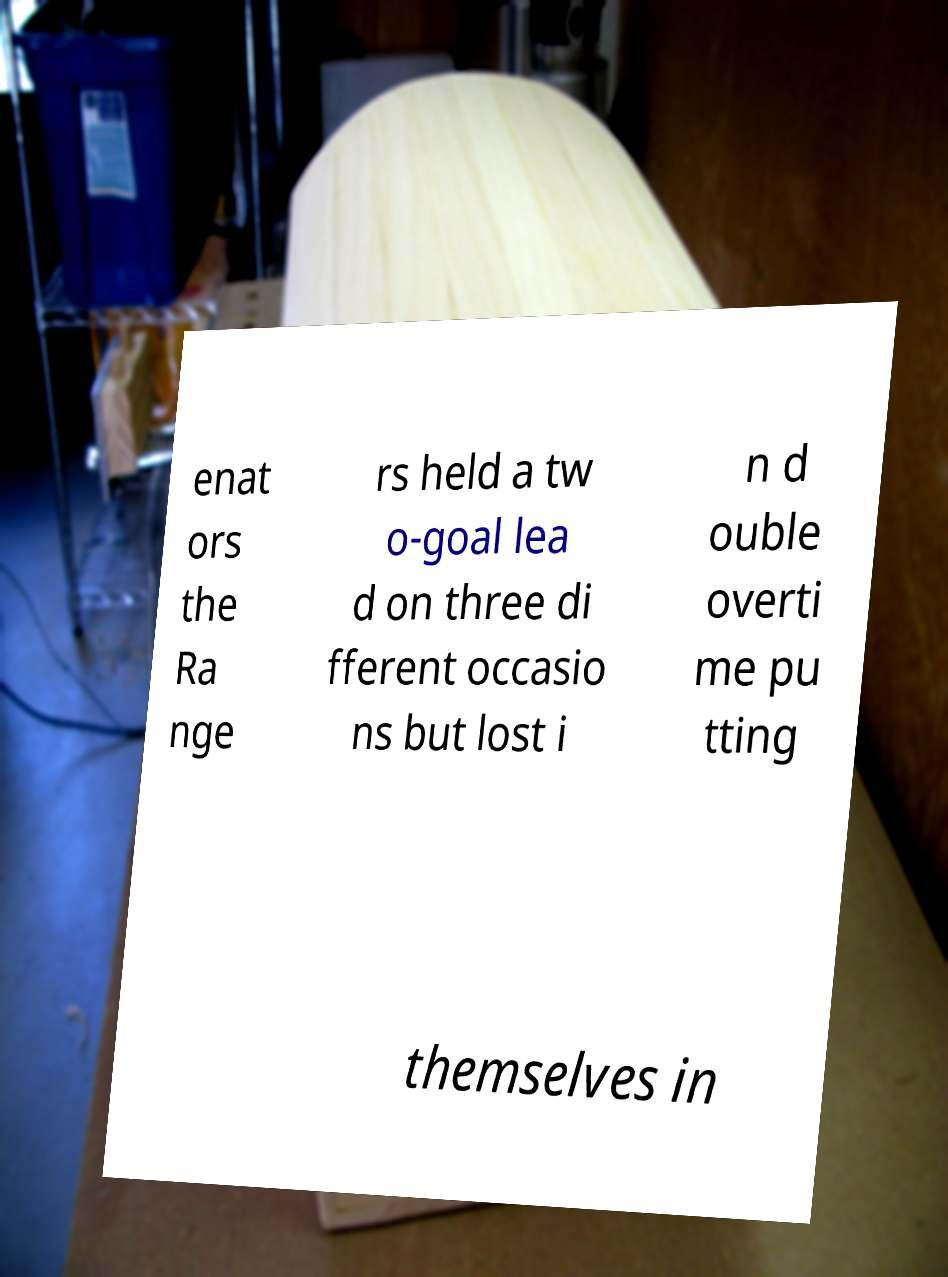Please read and relay the text visible in this image. What does it say? enat ors the Ra nge rs held a tw o-goal lea d on three di fferent occasio ns but lost i n d ouble overti me pu tting themselves in 